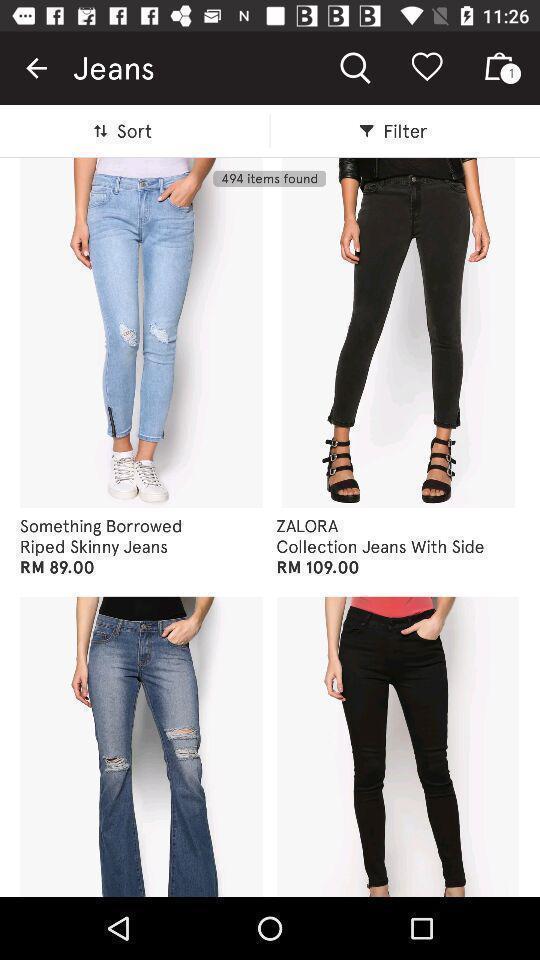Describe the key features of this screenshot. Search page with list of brands in the shopping app. 